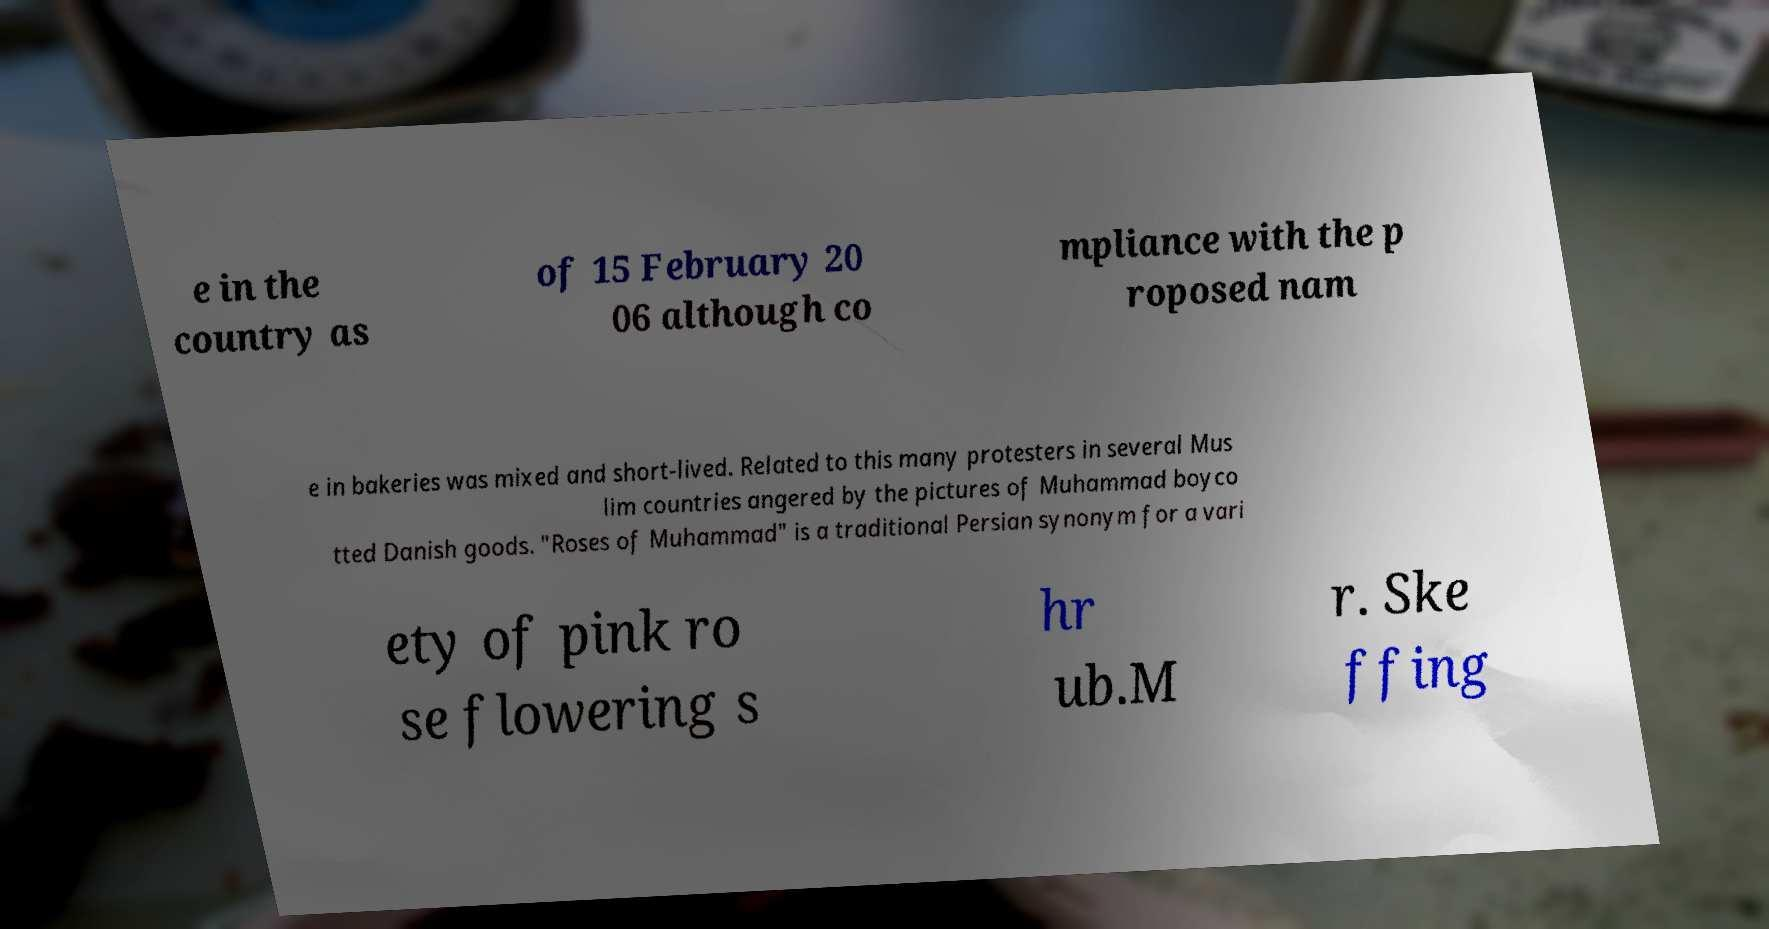There's text embedded in this image that I need extracted. Can you transcribe it verbatim? e in the country as of 15 February 20 06 although co mpliance with the p roposed nam e in bakeries was mixed and short-lived. Related to this many protesters in several Mus lim countries angered by the pictures of Muhammad boyco tted Danish goods. "Roses of Muhammad" is a traditional Persian synonym for a vari ety of pink ro se flowering s hr ub.M r. Ske ffing 